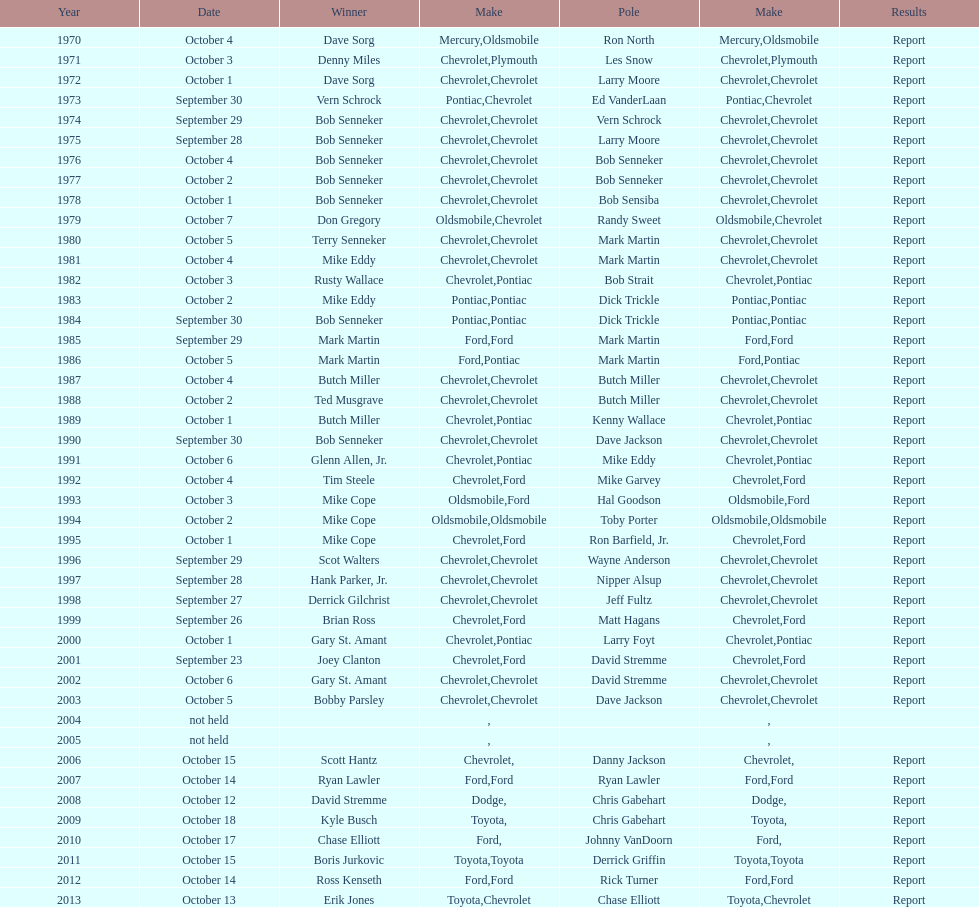How many continuous triumphs did bob senneker accomplish? 5. 